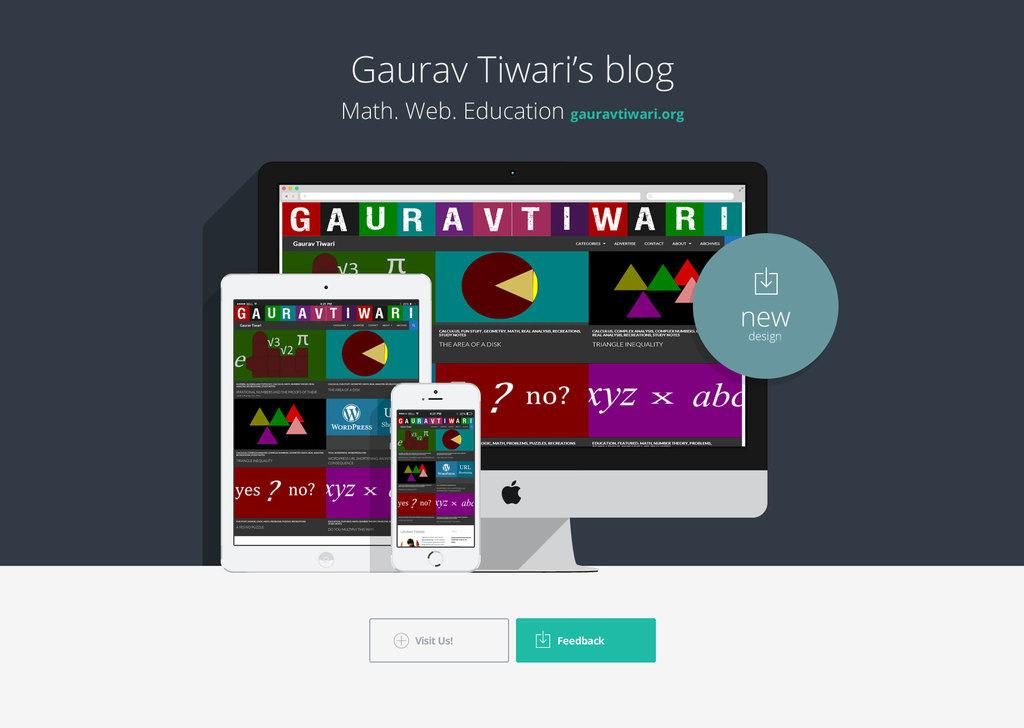<image>
Render a clear and concise summary of the photo. Colorful displays for the Gaurav Tiwari's blog shown on a several devices. 